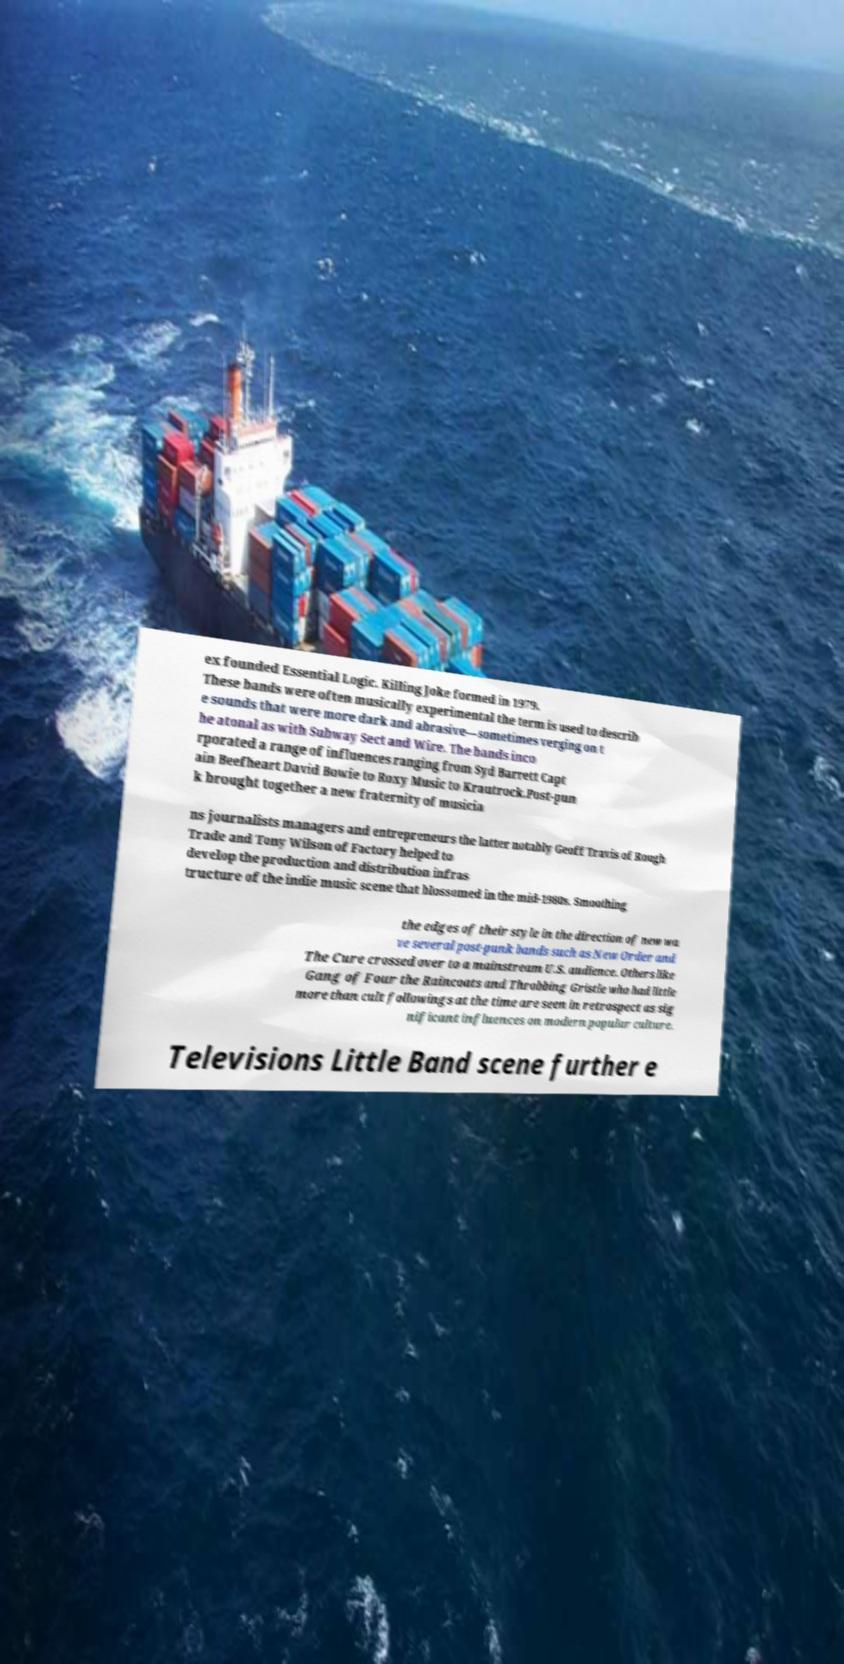What messages or text are displayed in this image? I need them in a readable, typed format. ex founded Essential Logic. Killing Joke formed in 1979. These bands were often musically experimental the term is used to describ e sounds that were more dark and abrasive—sometimes verging on t he atonal as with Subway Sect and Wire. The bands inco rporated a range of influences ranging from Syd Barrett Capt ain Beefheart David Bowie to Roxy Music to Krautrock.Post-pun k brought together a new fraternity of musicia ns journalists managers and entrepreneurs the latter notably Geoff Travis of Rough Trade and Tony Wilson of Factory helped to develop the production and distribution infras tructure of the indie music scene that blossomed in the mid-1980s. Smoothing the edges of their style in the direction of new wa ve several post-punk bands such as New Order and The Cure crossed over to a mainstream U.S. audience. Others like Gang of Four the Raincoats and Throbbing Gristle who had little more than cult followings at the time are seen in retrospect as sig nificant influences on modern popular culture. Televisions Little Band scene further e 